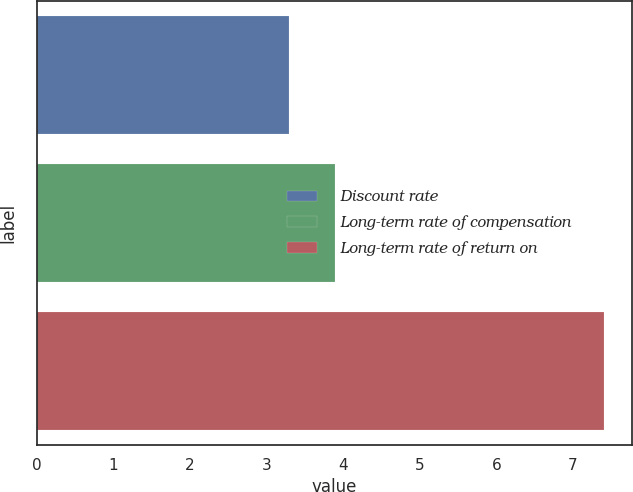Convert chart. <chart><loc_0><loc_0><loc_500><loc_500><bar_chart><fcel>Discount rate<fcel>Long-term rate of compensation<fcel>Long-term rate of return on<nl><fcel>3.3<fcel>3.9<fcel>7.4<nl></chart> 